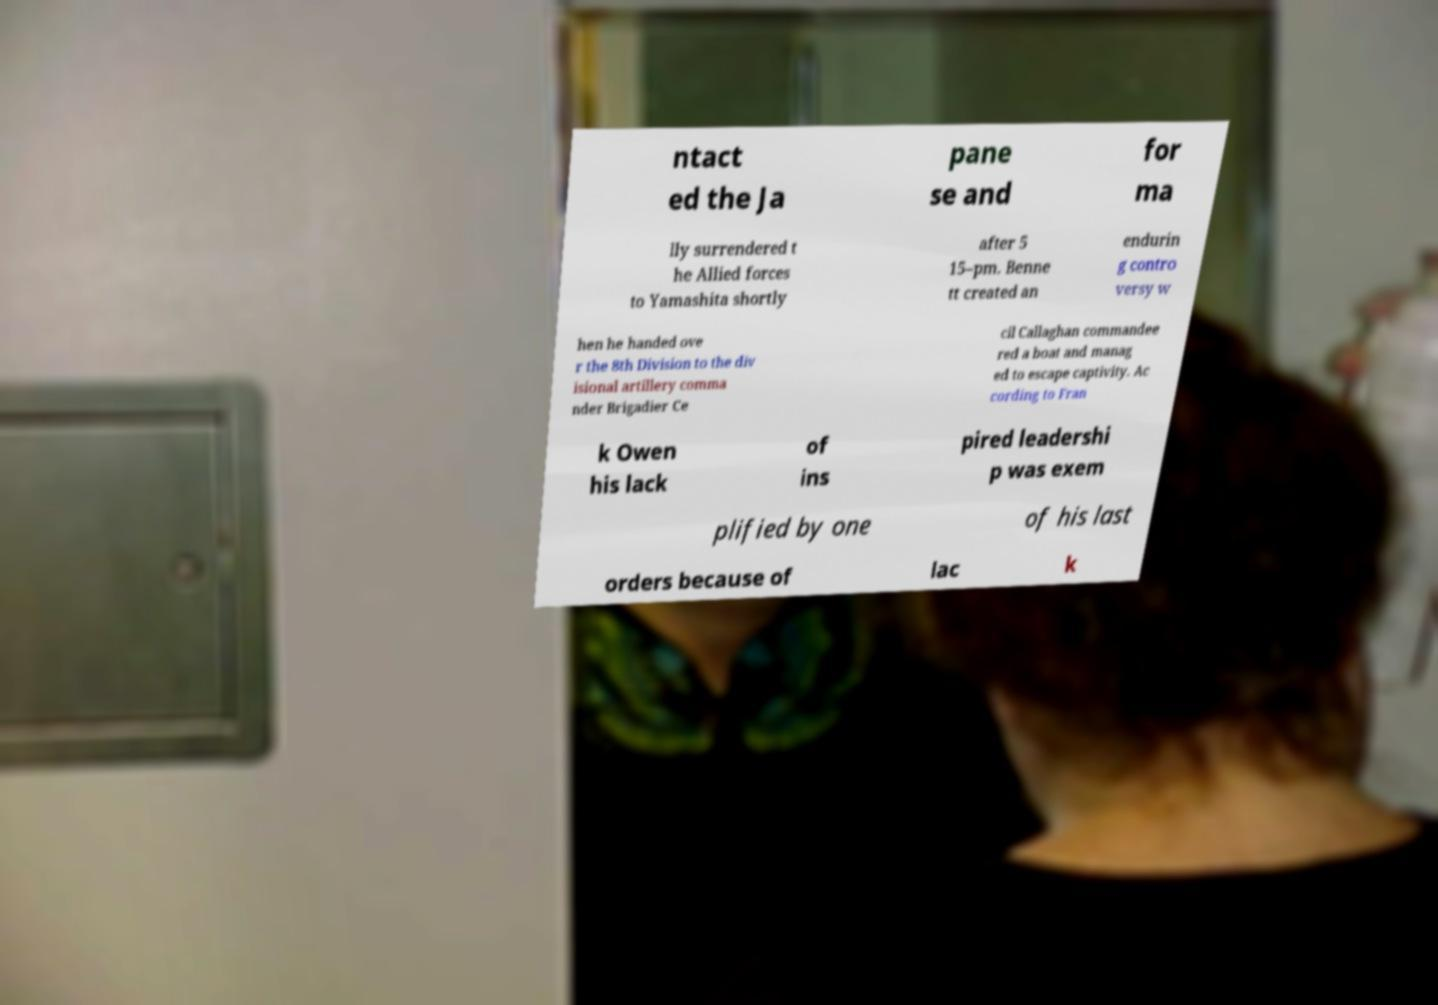There's text embedded in this image that I need extracted. Can you transcribe it verbatim? ntact ed the Ja pane se and for ma lly surrendered t he Allied forces to Yamashita shortly after 5 15–pm. Benne tt created an endurin g contro versy w hen he handed ove r the 8th Division to the div isional artillery comma nder Brigadier Ce cil Callaghan commandee red a boat and manag ed to escape captivity. Ac cording to Fran k Owen his lack of ins pired leadershi p was exem plified by one of his last orders because of lac k 